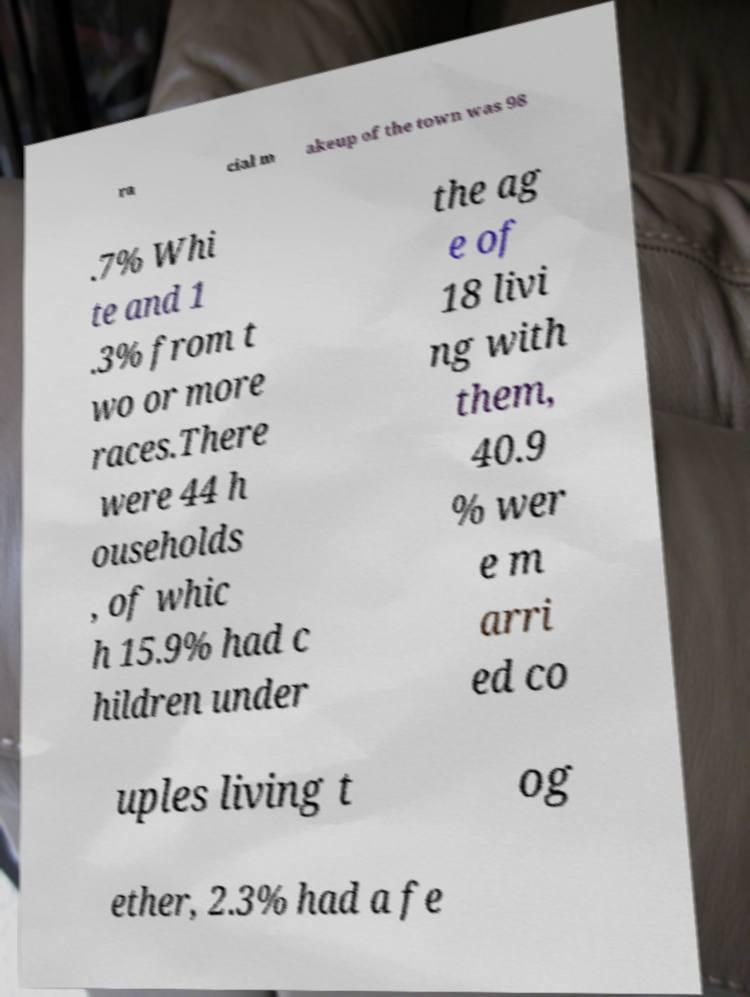What messages or text are displayed in this image? I need them in a readable, typed format. ra cial m akeup of the town was 98 .7% Whi te and 1 .3% from t wo or more races.There were 44 h ouseholds , of whic h 15.9% had c hildren under the ag e of 18 livi ng with them, 40.9 % wer e m arri ed co uples living t og ether, 2.3% had a fe 